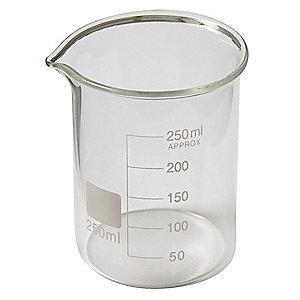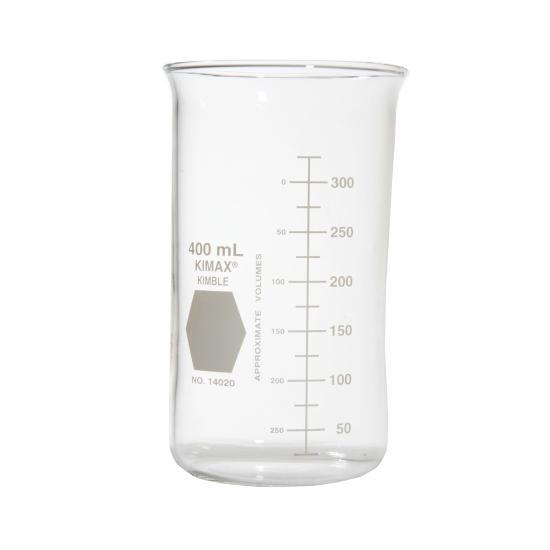The first image is the image on the left, the second image is the image on the right. Considering the images on both sides, is "There are at most two beakers." valid? Answer yes or no. Yes. The first image is the image on the left, the second image is the image on the right. Given the left and right images, does the statement "All of the measuring containers appear to be empty of liquid." hold true? Answer yes or no. Yes. 